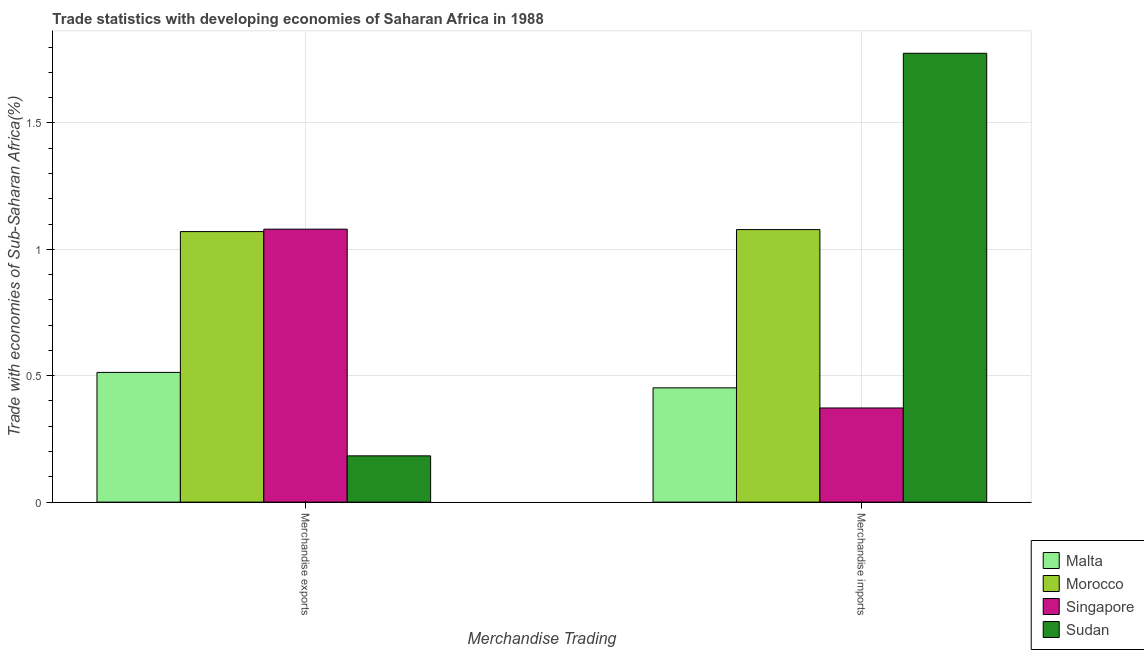Are the number of bars on each tick of the X-axis equal?
Ensure brevity in your answer.  Yes. How many bars are there on the 2nd tick from the left?
Provide a succinct answer. 4. What is the merchandise imports in Morocco?
Your response must be concise. 1.08. Across all countries, what is the maximum merchandise imports?
Provide a short and direct response. 1.78. Across all countries, what is the minimum merchandise exports?
Provide a succinct answer. 0.18. In which country was the merchandise imports maximum?
Give a very brief answer. Sudan. In which country was the merchandise exports minimum?
Your answer should be compact. Sudan. What is the total merchandise exports in the graph?
Provide a short and direct response. 2.85. What is the difference between the merchandise exports in Malta and that in Morocco?
Ensure brevity in your answer.  -0.56. What is the difference between the merchandise imports in Singapore and the merchandise exports in Sudan?
Give a very brief answer. 0.19. What is the average merchandise imports per country?
Make the answer very short. 0.92. What is the difference between the merchandise exports and merchandise imports in Malta?
Give a very brief answer. 0.06. In how many countries, is the merchandise imports greater than 0.4 %?
Provide a succinct answer. 3. What is the ratio of the merchandise imports in Singapore to that in Sudan?
Provide a short and direct response. 0.21. Is the merchandise exports in Morocco less than that in Sudan?
Keep it short and to the point. No. In how many countries, is the merchandise exports greater than the average merchandise exports taken over all countries?
Ensure brevity in your answer.  2. What does the 4th bar from the left in Merchandise exports represents?
Make the answer very short. Sudan. What does the 4th bar from the right in Merchandise imports represents?
Your response must be concise. Malta. How many bars are there?
Keep it short and to the point. 8. Are all the bars in the graph horizontal?
Provide a succinct answer. No. How many countries are there in the graph?
Provide a short and direct response. 4. Are the values on the major ticks of Y-axis written in scientific E-notation?
Ensure brevity in your answer.  No. Does the graph contain any zero values?
Provide a succinct answer. No. Does the graph contain grids?
Ensure brevity in your answer.  Yes. Where does the legend appear in the graph?
Ensure brevity in your answer.  Bottom right. How many legend labels are there?
Ensure brevity in your answer.  4. What is the title of the graph?
Provide a succinct answer. Trade statistics with developing economies of Saharan Africa in 1988. Does "Bahamas" appear as one of the legend labels in the graph?
Provide a succinct answer. No. What is the label or title of the X-axis?
Offer a very short reply. Merchandise Trading. What is the label or title of the Y-axis?
Give a very brief answer. Trade with economies of Sub-Saharan Africa(%). What is the Trade with economies of Sub-Saharan Africa(%) of Malta in Merchandise exports?
Provide a short and direct response. 0.51. What is the Trade with economies of Sub-Saharan Africa(%) in Morocco in Merchandise exports?
Ensure brevity in your answer.  1.07. What is the Trade with economies of Sub-Saharan Africa(%) in Singapore in Merchandise exports?
Provide a short and direct response. 1.08. What is the Trade with economies of Sub-Saharan Africa(%) of Sudan in Merchandise exports?
Provide a short and direct response. 0.18. What is the Trade with economies of Sub-Saharan Africa(%) in Malta in Merchandise imports?
Offer a terse response. 0.45. What is the Trade with economies of Sub-Saharan Africa(%) in Morocco in Merchandise imports?
Give a very brief answer. 1.08. What is the Trade with economies of Sub-Saharan Africa(%) in Singapore in Merchandise imports?
Make the answer very short. 0.37. What is the Trade with economies of Sub-Saharan Africa(%) of Sudan in Merchandise imports?
Make the answer very short. 1.78. Across all Merchandise Trading, what is the maximum Trade with economies of Sub-Saharan Africa(%) of Malta?
Offer a very short reply. 0.51. Across all Merchandise Trading, what is the maximum Trade with economies of Sub-Saharan Africa(%) of Morocco?
Keep it short and to the point. 1.08. Across all Merchandise Trading, what is the maximum Trade with economies of Sub-Saharan Africa(%) in Singapore?
Offer a very short reply. 1.08. Across all Merchandise Trading, what is the maximum Trade with economies of Sub-Saharan Africa(%) of Sudan?
Offer a terse response. 1.78. Across all Merchandise Trading, what is the minimum Trade with economies of Sub-Saharan Africa(%) of Malta?
Provide a short and direct response. 0.45. Across all Merchandise Trading, what is the minimum Trade with economies of Sub-Saharan Africa(%) of Morocco?
Provide a short and direct response. 1.07. Across all Merchandise Trading, what is the minimum Trade with economies of Sub-Saharan Africa(%) in Singapore?
Give a very brief answer. 0.37. Across all Merchandise Trading, what is the minimum Trade with economies of Sub-Saharan Africa(%) of Sudan?
Provide a succinct answer. 0.18. What is the total Trade with economies of Sub-Saharan Africa(%) of Malta in the graph?
Offer a very short reply. 0.97. What is the total Trade with economies of Sub-Saharan Africa(%) of Morocco in the graph?
Ensure brevity in your answer.  2.15. What is the total Trade with economies of Sub-Saharan Africa(%) of Singapore in the graph?
Offer a very short reply. 1.45. What is the total Trade with economies of Sub-Saharan Africa(%) in Sudan in the graph?
Provide a succinct answer. 1.96. What is the difference between the Trade with economies of Sub-Saharan Africa(%) of Malta in Merchandise exports and that in Merchandise imports?
Your answer should be compact. 0.06. What is the difference between the Trade with economies of Sub-Saharan Africa(%) of Morocco in Merchandise exports and that in Merchandise imports?
Make the answer very short. -0.01. What is the difference between the Trade with economies of Sub-Saharan Africa(%) of Singapore in Merchandise exports and that in Merchandise imports?
Provide a succinct answer. 0.71. What is the difference between the Trade with economies of Sub-Saharan Africa(%) in Sudan in Merchandise exports and that in Merchandise imports?
Offer a terse response. -1.59. What is the difference between the Trade with economies of Sub-Saharan Africa(%) of Malta in Merchandise exports and the Trade with economies of Sub-Saharan Africa(%) of Morocco in Merchandise imports?
Keep it short and to the point. -0.56. What is the difference between the Trade with economies of Sub-Saharan Africa(%) in Malta in Merchandise exports and the Trade with economies of Sub-Saharan Africa(%) in Singapore in Merchandise imports?
Your answer should be compact. 0.14. What is the difference between the Trade with economies of Sub-Saharan Africa(%) of Malta in Merchandise exports and the Trade with economies of Sub-Saharan Africa(%) of Sudan in Merchandise imports?
Your response must be concise. -1.26. What is the difference between the Trade with economies of Sub-Saharan Africa(%) of Morocco in Merchandise exports and the Trade with economies of Sub-Saharan Africa(%) of Singapore in Merchandise imports?
Provide a succinct answer. 0.7. What is the difference between the Trade with economies of Sub-Saharan Africa(%) in Morocco in Merchandise exports and the Trade with economies of Sub-Saharan Africa(%) in Sudan in Merchandise imports?
Keep it short and to the point. -0.71. What is the difference between the Trade with economies of Sub-Saharan Africa(%) in Singapore in Merchandise exports and the Trade with economies of Sub-Saharan Africa(%) in Sudan in Merchandise imports?
Keep it short and to the point. -0.7. What is the average Trade with economies of Sub-Saharan Africa(%) of Malta per Merchandise Trading?
Keep it short and to the point. 0.48. What is the average Trade with economies of Sub-Saharan Africa(%) of Morocco per Merchandise Trading?
Your response must be concise. 1.07. What is the average Trade with economies of Sub-Saharan Africa(%) of Singapore per Merchandise Trading?
Make the answer very short. 0.73. What is the average Trade with economies of Sub-Saharan Africa(%) of Sudan per Merchandise Trading?
Offer a very short reply. 0.98. What is the difference between the Trade with economies of Sub-Saharan Africa(%) of Malta and Trade with economies of Sub-Saharan Africa(%) of Morocco in Merchandise exports?
Your response must be concise. -0.56. What is the difference between the Trade with economies of Sub-Saharan Africa(%) of Malta and Trade with economies of Sub-Saharan Africa(%) of Singapore in Merchandise exports?
Make the answer very short. -0.57. What is the difference between the Trade with economies of Sub-Saharan Africa(%) of Malta and Trade with economies of Sub-Saharan Africa(%) of Sudan in Merchandise exports?
Provide a succinct answer. 0.33. What is the difference between the Trade with economies of Sub-Saharan Africa(%) of Morocco and Trade with economies of Sub-Saharan Africa(%) of Singapore in Merchandise exports?
Keep it short and to the point. -0.01. What is the difference between the Trade with economies of Sub-Saharan Africa(%) in Morocco and Trade with economies of Sub-Saharan Africa(%) in Sudan in Merchandise exports?
Ensure brevity in your answer.  0.89. What is the difference between the Trade with economies of Sub-Saharan Africa(%) of Singapore and Trade with economies of Sub-Saharan Africa(%) of Sudan in Merchandise exports?
Give a very brief answer. 0.9. What is the difference between the Trade with economies of Sub-Saharan Africa(%) in Malta and Trade with economies of Sub-Saharan Africa(%) in Morocco in Merchandise imports?
Your answer should be compact. -0.63. What is the difference between the Trade with economies of Sub-Saharan Africa(%) in Malta and Trade with economies of Sub-Saharan Africa(%) in Singapore in Merchandise imports?
Your answer should be compact. 0.08. What is the difference between the Trade with economies of Sub-Saharan Africa(%) in Malta and Trade with economies of Sub-Saharan Africa(%) in Sudan in Merchandise imports?
Offer a very short reply. -1.32. What is the difference between the Trade with economies of Sub-Saharan Africa(%) of Morocco and Trade with economies of Sub-Saharan Africa(%) of Singapore in Merchandise imports?
Offer a terse response. 0.71. What is the difference between the Trade with economies of Sub-Saharan Africa(%) in Morocco and Trade with economies of Sub-Saharan Africa(%) in Sudan in Merchandise imports?
Your answer should be compact. -0.7. What is the difference between the Trade with economies of Sub-Saharan Africa(%) in Singapore and Trade with economies of Sub-Saharan Africa(%) in Sudan in Merchandise imports?
Ensure brevity in your answer.  -1.4. What is the ratio of the Trade with economies of Sub-Saharan Africa(%) in Malta in Merchandise exports to that in Merchandise imports?
Offer a very short reply. 1.14. What is the ratio of the Trade with economies of Sub-Saharan Africa(%) of Morocco in Merchandise exports to that in Merchandise imports?
Offer a terse response. 0.99. What is the ratio of the Trade with economies of Sub-Saharan Africa(%) in Singapore in Merchandise exports to that in Merchandise imports?
Provide a succinct answer. 2.9. What is the ratio of the Trade with economies of Sub-Saharan Africa(%) of Sudan in Merchandise exports to that in Merchandise imports?
Your response must be concise. 0.1. What is the difference between the highest and the second highest Trade with economies of Sub-Saharan Africa(%) in Malta?
Keep it short and to the point. 0.06. What is the difference between the highest and the second highest Trade with economies of Sub-Saharan Africa(%) of Morocco?
Keep it short and to the point. 0.01. What is the difference between the highest and the second highest Trade with economies of Sub-Saharan Africa(%) in Singapore?
Give a very brief answer. 0.71. What is the difference between the highest and the second highest Trade with economies of Sub-Saharan Africa(%) of Sudan?
Your answer should be very brief. 1.59. What is the difference between the highest and the lowest Trade with economies of Sub-Saharan Africa(%) in Malta?
Keep it short and to the point. 0.06. What is the difference between the highest and the lowest Trade with economies of Sub-Saharan Africa(%) of Morocco?
Your response must be concise. 0.01. What is the difference between the highest and the lowest Trade with economies of Sub-Saharan Africa(%) of Singapore?
Keep it short and to the point. 0.71. What is the difference between the highest and the lowest Trade with economies of Sub-Saharan Africa(%) in Sudan?
Your answer should be very brief. 1.59. 